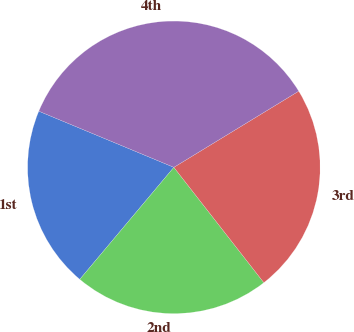<chart> <loc_0><loc_0><loc_500><loc_500><pie_chart><fcel>1st<fcel>2nd<fcel>3rd<fcel>4th<nl><fcel>20.15%<fcel>21.66%<fcel>23.17%<fcel>35.01%<nl></chart> 